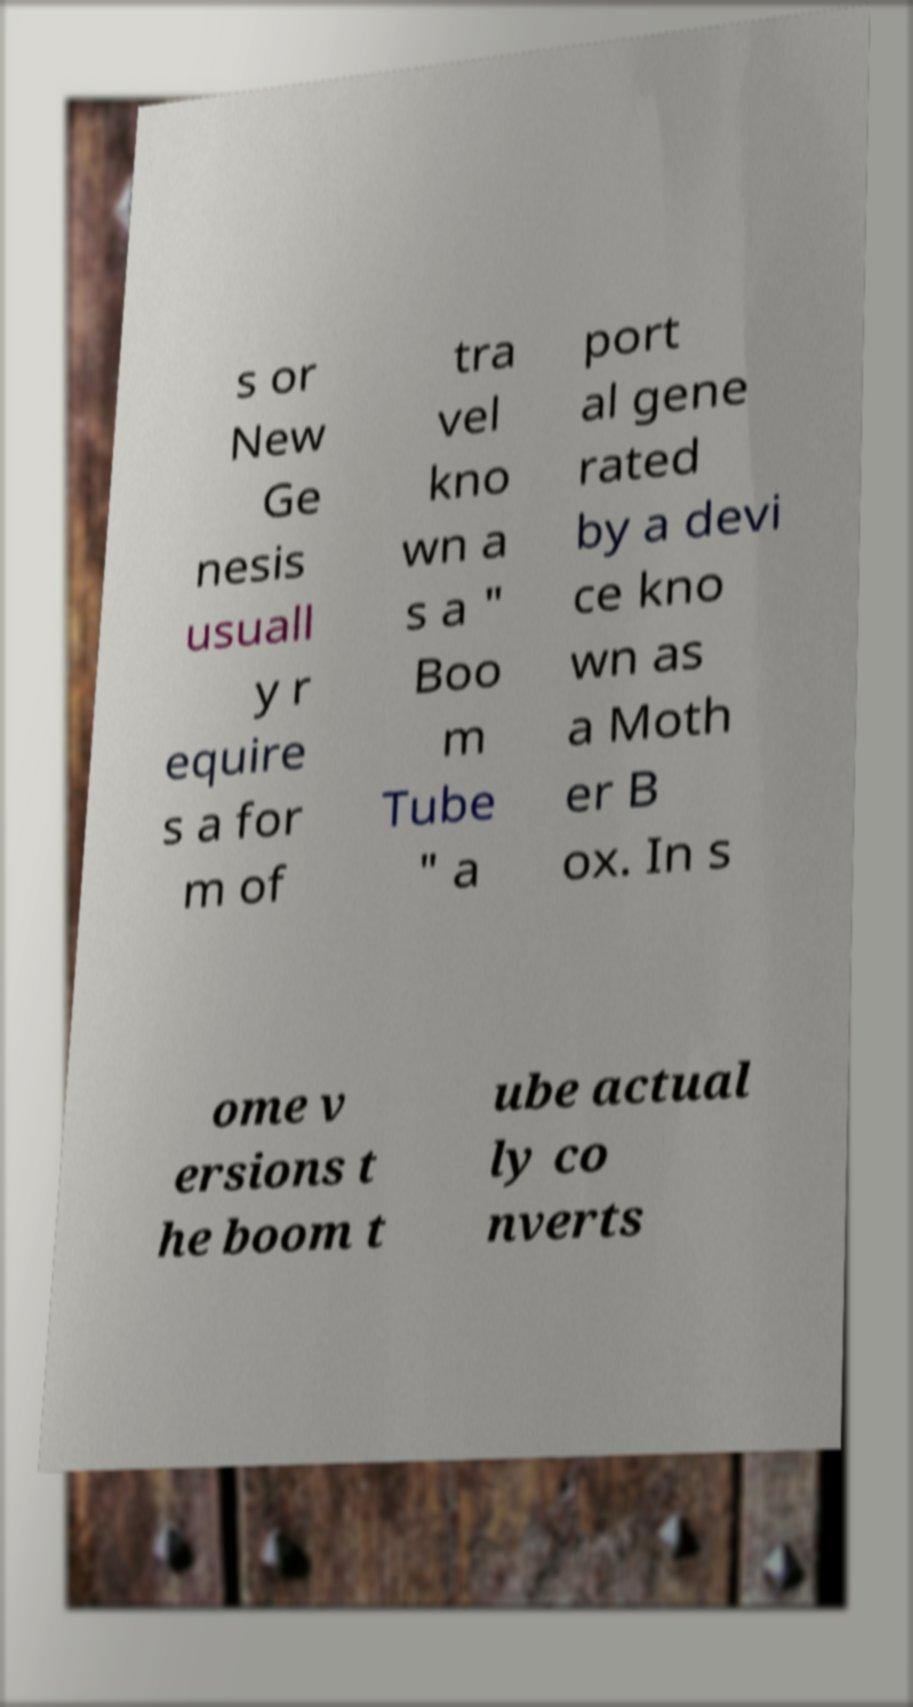Could you assist in decoding the text presented in this image and type it out clearly? s or New Ge nesis usuall y r equire s a for m of tra vel kno wn a s a " Boo m Tube " a port al gene rated by a devi ce kno wn as a Moth er B ox. In s ome v ersions t he boom t ube actual ly co nverts 